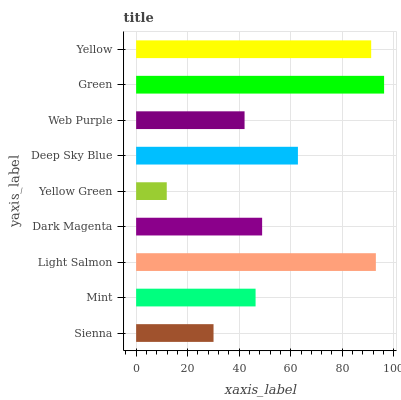Is Yellow Green the minimum?
Answer yes or no. Yes. Is Green the maximum?
Answer yes or no. Yes. Is Mint the minimum?
Answer yes or no. No. Is Mint the maximum?
Answer yes or no. No. Is Mint greater than Sienna?
Answer yes or no. Yes. Is Sienna less than Mint?
Answer yes or no. Yes. Is Sienna greater than Mint?
Answer yes or no. No. Is Mint less than Sienna?
Answer yes or no. No. Is Dark Magenta the high median?
Answer yes or no. Yes. Is Dark Magenta the low median?
Answer yes or no. Yes. Is Light Salmon the high median?
Answer yes or no. No. Is Light Salmon the low median?
Answer yes or no. No. 